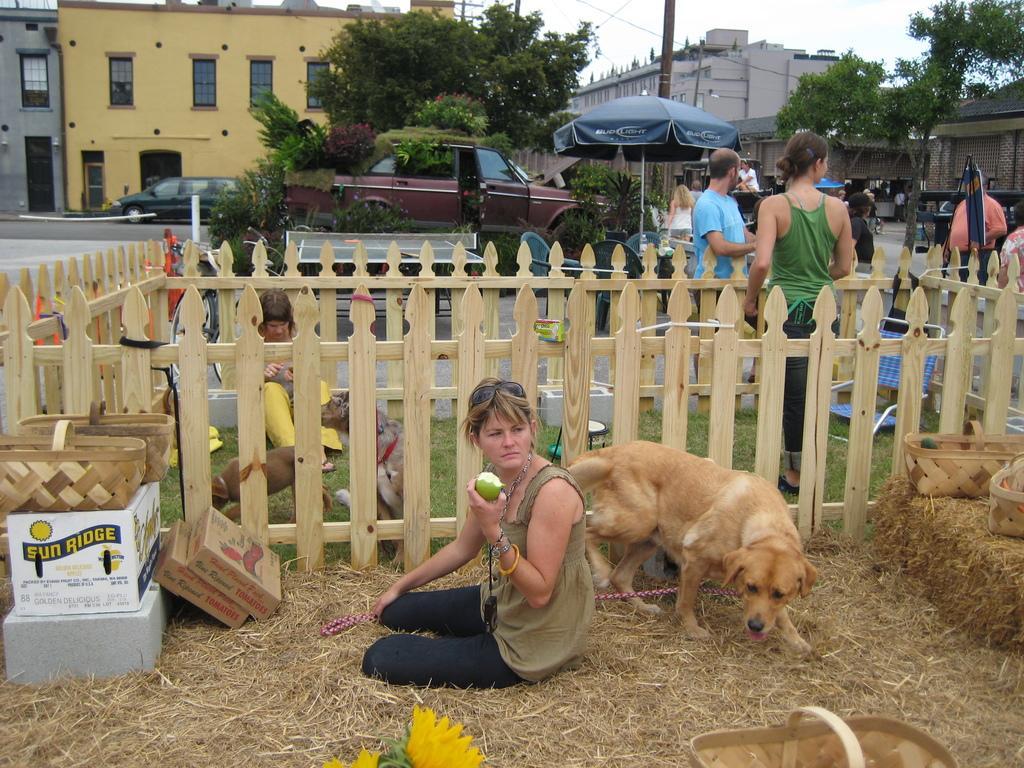In one or two sentences, can you explain what this image depicts? The women wearing black pant is holding a fruit in her hand and there is a dog behind her and there are group of people,cars,trees and buildings in the background. 